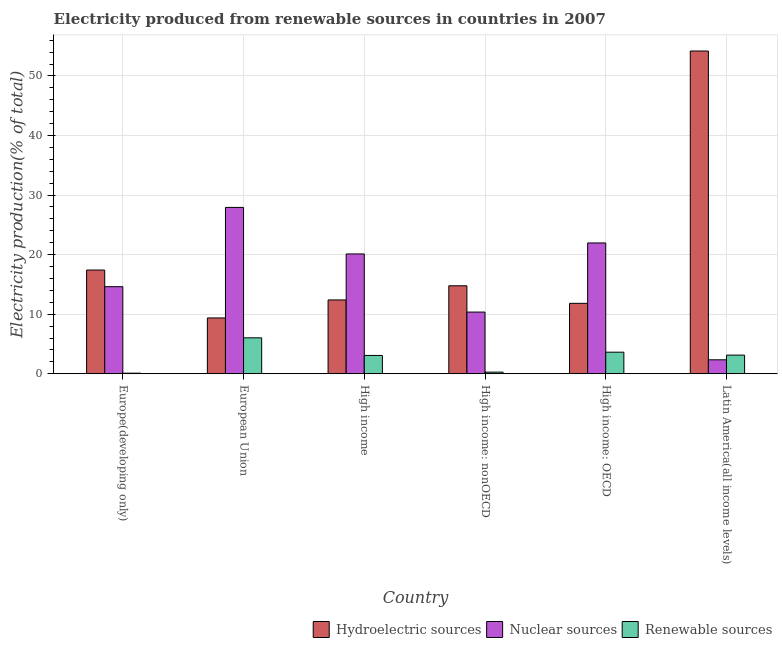How many different coloured bars are there?
Your answer should be compact. 3. How many groups of bars are there?
Provide a short and direct response. 6. How many bars are there on the 2nd tick from the left?
Offer a very short reply. 3. What is the label of the 6th group of bars from the left?
Your answer should be compact. Latin America(all income levels). In how many cases, is the number of bars for a given country not equal to the number of legend labels?
Keep it short and to the point. 0. What is the percentage of electricity produced by hydroelectric sources in High income: OECD?
Ensure brevity in your answer.  11.82. Across all countries, what is the maximum percentage of electricity produced by nuclear sources?
Your answer should be very brief. 27.93. Across all countries, what is the minimum percentage of electricity produced by nuclear sources?
Your answer should be very brief. 2.34. In which country was the percentage of electricity produced by renewable sources minimum?
Ensure brevity in your answer.  Europe(developing only). What is the total percentage of electricity produced by renewable sources in the graph?
Ensure brevity in your answer.  16.22. What is the difference between the percentage of electricity produced by renewable sources in European Union and that in Latin America(all income levels)?
Your answer should be compact. 2.9. What is the difference between the percentage of electricity produced by hydroelectric sources in Latin America(all income levels) and the percentage of electricity produced by nuclear sources in High income?
Make the answer very short. 34.07. What is the average percentage of electricity produced by renewable sources per country?
Give a very brief answer. 2.7. What is the difference between the percentage of electricity produced by renewable sources and percentage of electricity produced by hydroelectric sources in European Union?
Provide a succinct answer. -3.34. What is the ratio of the percentage of electricity produced by renewable sources in Europe(developing only) to that in European Union?
Ensure brevity in your answer.  0.02. Is the percentage of electricity produced by renewable sources in European Union less than that in High income: nonOECD?
Provide a succinct answer. No. Is the difference between the percentage of electricity produced by renewable sources in Europe(developing only) and Latin America(all income levels) greater than the difference between the percentage of electricity produced by hydroelectric sources in Europe(developing only) and Latin America(all income levels)?
Provide a short and direct response. Yes. What is the difference between the highest and the second highest percentage of electricity produced by hydroelectric sources?
Provide a succinct answer. 36.77. What is the difference between the highest and the lowest percentage of electricity produced by renewable sources?
Ensure brevity in your answer.  5.94. In how many countries, is the percentage of electricity produced by renewable sources greater than the average percentage of electricity produced by renewable sources taken over all countries?
Your response must be concise. 4. Is the sum of the percentage of electricity produced by renewable sources in European Union and High income greater than the maximum percentage of electricity produced by hydroelectric sources across all countries?
Ensure brevity in your answer.  No. What does the 3rd bar from the left in High income: nonOECD represents?
Your answer should be compact. Renewable sources. What does the 2nd bar from the right in Europe(developing only) represents?
Give a very brief answer. Nuclear sources. Are all the bars in the graph horizontal?
Your response must be concise. No. What is the difference between two consecutive major ticks on the Y-axis?
Give a very brief answer. 10. Are the values on the major ticks of Y-axis written in scientific E-notation?
Keep it short and to the point. No. Does the graph contain any zero values?
Your answer should be very brief. No. How many legend labels are there?
Provide a short and direct response. 3. How are the legend labels stacked?
Your answer should be very brief. Horizontal. What is the title of the graph?
Your answer should be compact. Electricity produced from renewable sources in countries in 2007. What is the label or title of the Y-axis?
Provide a short and direct response. Electricity production(% of total). What is the Electricity production(% of total) of Hydroelectric sources in Europe(developing only)?
Your answer should be very brief. 17.41. What is the Electricity production(% of total) of Nuclear sources in Europe(developing only)?
Offer a terse response. 14.62. What is the Electricity production(% of total) in Renewable sources in Europe(developing only)?
Your answer should be compact. 0.09. What is the Electricity production(% of total) of Hydroelectric sources in European Union?
Your answer should be very brief. 9.37. What is the Electricity production(% of total) of Nuclear sources in European Union?
Provide a succinct answer. 27.93. What is the Electricity production(% of total) of Renewable sources in European Union?
Make the answer very short. 6.03. What is the Electricity production(% of total) in Hydroelectric sources in High income?
Provide a succinct answer. 12.39. What is the Electricity production(% of total) of Nuclear sources in High income?
Offer a terse response. 20.11. What is the Electricity production(% of total) of Renewable sources in High income?
Ensure brevity in your answer.  3.07. What is the Electricity production(% of total) in Hydroelectric sources in High income: nonOECD?
Make the answer very short. 14.77. What is the Electricity production(% of total) of Nuclear sources in High income: nonOECD?
Ensure brevity in your answer.  10.36. What is the Electricity production(% of total) of Renewable sources in High income: nonOECD?
Your response must be concise. 0.27. What is the Electricity production(% of total) of Hydroelectric sources in High income: OECD?
Your answer should be very brief. 11.82. What is the Electricity production(% of total) in Nuclear sources in High income: OECD?
Provide a succinct answer. 21.96. What is the Electricity production(% of total) in Renewable sources in High income: OECD?
Your response must be concise. 3.62. What is the Electricity production(% of total) in Hydroelectric sources in Latin America(all income levels)?
Your answer should be compact. 54.19. What is the Electricity production(% of total) in Nuclear sources in Latin America(all income levels)?
Provide a succinct answer. 2.34. What is the Electricity production(% of total) in Renewable sources in Latin America(all income levels)?
Your response must be concise. 3.13. Across all countries, what is the maximum Electricity production(% of total) of Hydroelectric sources?
Offer a very short reply. 54.19. Across all countries, what is the maximum Electricity production(% of total) in Nuclear sources?
Your response must be concise. 27.93. Across all countries, what is the maximum Electricity production(% of total) in Renewable sources?
Make the answer very short. 6.03. Across all countries, what is the minimum Electricity production(% of total) of Hydroelectric sources?
Ensure brevity in your answer.  9.37. Across all countries, what is the minimum Electricity production(% of total) in Nuclear sources?
Your answer should be very brief. 2.34. Across all countries, what is the minimum Electricity production(% of total) in Renewable sources?
Provide a succinct answer. 0.09. What is the total Electricity production(% of total) in Hydroelectric sources in the graph?
Keep it short and to the point. 119.94. What is the total Electricity production(% of total) of Nuclear sources in the graph?
Give a very brief answer. 97.31. What is the total Electricity production(% of total) in Renewable sources in the graph?
Provide a short and direct response. 16.22. What is the difference between the Electricity production(% of total) of Hydroelectric sources in Europe(developing only) and that in European Union?
Give a very brief answer. 8.05. What is the difference between the Electricity production(% of total) of Nuclear sources in Europe(developing only) and that in European Union?
Your response must be concise. -13.31. What is the difference between the Electricity production(% of total) in Renewable sources in Europe(developing only) and that in European Union?
Give a very brief answer. -5.94. What is the difference between the Electricity production(% of total) in Hydroelectric sources in Europe(developing only) and that in High income?
Give a very brief answer. 5.02. What is the difference between the Electricity production(% of total) in Nuclear sources in Europe(developing only) and that in High income?
Keep it short and to the point. -5.5. What is the difference between the Electricity production(% of total) of Renewable sources in Europe(developing only) and that in High income?
Provide a short and direct response. -2.98. What is the difference between the Electricity production(% of total) in Hydroelectric sources in Europe(developing only) and that in High income: nonOECD?
Ensure brevity in your answer.  2.65. What is the difference between the Electricity production(% of total) in Nuclear sources in Europe(developing only) and that in High income: nonOECD?
Ensure brevity in your answer.  4.26. What is the difference between the Electricity production(% of total) of Renewable sources in Europe(developing only) and that in High income: nonOECD?
Give a very brief answer. -0.18. What is the difference between the Electricity production(% of total) in Hydroelectric sources in Europe(developing only) and that in High income: OECD?
Provide a succinct answer. 5.59. What is the difference between the Electricity production(% of total) of Nuclear sources in Europe(developing only) and that in High income: OECD?
Your answer should be compact. -7.34. What is the difference between the Electricity production(% of total) of Renewable sources in Europe(developing only) and that in High income: OECD?
Offer a terse response. -3.53. What is the difference between the Electricity production(% of total) of Hydroelectric sources in Europe(developing only) and that in Latin America(all income levels)?
Your answer should be very brief. -36.77. What is the difference between the Electricity production(% of total) in Nuclear sources in Europe(developing only) and that in Latin America(all income levels)?
Keep it short and to the point. 12.28. What is the difference between the Electricity production(% of total) of Renewable sources in Europe(developing only) and that in Latin America(all income levels)?
Ensure brevity in your answer.  -3.03. What is the difference between the Electricity production(% of total) of Hydroelectric sources in European Union and that in High income?
Keep it short and to the point. -3.02. What is the difference between the Electricity production(% of total) of Nuclear sources in European Union and that in High income?
Provide a succinct answer. 7.81. What is the difference between the Electricity production(% of total) in Renewable sources in European Union and that in High income?
Your answer should be very brief. 2.96. What is the difference between the Electricity production(% of total) in Hydroelectric sources in European Union and that in High income: nonOECD?
Provide a succinct answer. -5.4. What is the difference between the Electricity production(% of total) in Nuclear sources in European Union and that in High income: nonOECD?
Ensure brevity in your answer.  17.57. What is the difference between the Electricity production(% of total) of Renewable sources in European Union and that in High income: nonOECD?
Provide a succinct answer. 5.76. What is the difference between the Electricity production(% of total) in Hydroelectric sources in European Union and that in High income: OECD?
Keep it short and to the point. -2.45. What is the difference between the Electricity production(% of total) in Nuclear sources in European Union and that in High income: OECD?
Make the answer very short. 5.97. What is the difference between the Electricity production(% of total) in Renewable sources in European Union and that in High income: OECD?
Your answer should be very brief. 2.41. What is the difference between the Electricity production(% of total) of Hydroelectric sources in European Union and that in Latin America(all income levels)?
Provide a succinct answer. -44.82. What is the difference between the Electricity production(% of total) in Nuclear sources in European Union and that in Latin America(all income levels)?
Make the answer very short. 25.59. What is the difference between the Electricity production(% of total) in Renewable sources in European Union and that in Latin America(all income levels)?
Your answer should be compact. 2.9. What is the difference between the Electricity production(% of total) in Hydroelectric sources in High income and that in High income: nonOECD?
Provide a short and direct response. -2.38. What is the difference between the Electricity production(% of total) of Nuclear sources in High income and that in High income: nonOECD?
Your answer should be compact. 9.76. What is the difference between the Electricity production(% of total) in Renewable sources in High income and that in High income: nonOECD?
Your answer should be very brief. 2.8. What is the difference between the Electricity production(% of total) in Hydroelectric sources in High income and that in High income: OECD?
Provide a short and direct response. 0.57. What is the difference between the Electricity production(% of total) in Nuclear sources in High income and that in High income: OECD?
Your response must be concise. -1.85. What is the difference between the Electricity production(% of total) in Renewable sources in High income and that in High income: OECD?
Make the answer very short. -0.55. What is the difference between the Electricity production(% of total) in Hydroelectric sources in High income and that in Latin America(all income levels)?
Offer a terse response. -41.8. What is the difference between the Electricity production(% of total) in Nuclear sources in High income and that in Latin America(all income levels)?
Give a very brief answer. 17.77. What is the difference between the Electricity production(% of total) of Renewable sources in High income and that in Latin America(all income levels)?
Make the answer very short. -0.06. What is the difference between the Electricity production(% of total) in Hydroelectric sources in High income: nonOECD and that in High income: OECD?
Your answer should be very brief. 2.95. What is the difference between the Electricity production(% of total) of Nuclear sources in High income: nonOECD and that in High income: OECD?
Keep it short and to the point. -11.6. What is the difference between the Electricity production(% of total) of Renewable sources in High income: nonOECD and that in High income: OECD?
Your answer should be compact. -3.35. What is the difference between the Electricity production(% of total) of Hydroelectric sources in High income: nonOECD and that in Latin America(all income levels)?
Give a very brief answer. -39.42. What is the difference between the Electricity production(% of total) of Nuclear sources in High income: nonOECD and that in Latin America(all income levels)?
Keep it short and to the point. 8.02. What is the difference between the Electricity production(% of total) of Renewable sources in High income: nonOECD and that in Latin America(all income levels)?
Ensure brevity in your answer.  -2.85. What is the difference between the Electricity production(% of total) of Hydroelectric sources in High income: OECD and that in Latin America(all income levels)?
Give a very brief answer. -42.37. What is the difference between the Electricity production(% of total) in Nuclear sources in High income: OECD and that in Latin America(all income levels)?
Provide a succinct answer. 19.62. What is the difference between the Electricity production(% of total) of Renewable sources in High income: OECD and that in Latin America(all income levels)?
Keep it short and to the point. 0.49. What is the difference between the Electricity production(% of total) of Hydroelectric sources in Europe(developing only) and the Electricity production(% of total) of Nuclear sources in European Union?
Provide a succinct answer. -10.51. What is the difference between the Electricity production(% of total) of Hydroelectric sources in Europe(developing only) and the Electricity production(% of total) of Renewable sources in European Union?
Your answer should be very brief. 11.38. What is the difference between the Electricity production(% of total) of Nuclear sources in Europe(developing only) and the Electricity production(% of total) of Renewable sources in European Union?
Offer a very short reply. 8.58. What is the difference between the Electricity production(% of total) of Hydroelectric sources in Europe(developing only) and the Electricity production(% of total) of Nuclear sources in High income?
Provide a succinct answer. -2.7. What is the difference between the Electricity production(% of total) of Hydroelectric sources in Europe(developing only) and the Electricity production(% of total) of Renewable sources in High income?
Your answer should be very brief. 14.34. What is the difference between the Electricity production(% of total) in Nuclear sources in Europe(developing only) and the Electricity production(% of total) in Renewable sources in High income?
Provide a short and direct response. 11.54. What is the difference between the Electricity production(% of total) of Hydroelectric sources in Europe(developing only) and the Electricity production(% of total) of Nuclear sources in High income: nonOECD?
Your answer should be compact. 7.06. What is the difference between the Electricity production(% of total) of Hydroelectric sources in Europe(developing only) and the Electricity production(% of total) of Renewable sources in High income: nonOECD?
Offer a very short reply. 17.14. What is the difference between the Electricity production(% of total) in Nuclear sources in Europe(developing only) and the Electricity production(% of total) in Renewable sources in High income: nonOECD?
Provide a succinct answer. 14.34. What is the difference between the Electricity production(% of total) in Hydroelectric sources in Europe(developing only) and the Electricity production(% of total) in Nuclear sources in High income: OECD?
Make the answer very short. -4.55. What is the difference between the Electricity production(% of total) of Hydroelectric sources in Europe(developing only) and the Electricity production(% of total) of Renewable sources in High income: OECD?
Offer a very short reply. 13.79. What is the difference between the Electricity production(% of total) of Nuclear sources in Europe(developing only) and the Electricity production(% of total) of Renewable sources in High income: OECD?
Give a very brief answer. 11. What is the difference between the Electricity production(% of total) in Hydroelectric sources in Europe(developing only) and the Electricity production(% of total) in Nuclear sources in Latin America(all income levels)?
Offer a very short reply. 15.07. What is the difference between the Electricity production(% of total) of Hydroelectric sources in Europe(developing only) and the Electricity production(% of total) of Renewable sources in Latin America(all income levels)?
Give a very brief answer. 14.28. What is the difference between the Electricity production(% of total) in Nuclear sources in Europe(developing only) and the Electricity production(% of total) in Renewable sources in Latin America(all income levels)?
Keep it short and to the point. 11.49. What is the difference between the Electricity production(% of total) of Hydroelectric sources in European Union and the Electricity production(% of total) of Nuclear sources in High income?
Offer a very short reply. -10.75. What is the difference between the Electricity production(% of total) of Hydroelectric sources in European Union and the Electricity production(% of total) of Renewable sources in High income?
Make the answer very short. 6.29. What is the difference between the Electricity production(% of total) in Nuclear sources in European Union and the Electricity production(% of total) in Renewable sources in High income?
Keep it short and to the point. 24.85. What is the difference between the Electricity production(% of total) in Hydroelectric sources in European Union and the Electricity production(% of total) in Nuclear sources in High income: nonOECD?
Ensure brevity in your answer.  -0.99. What is the difference between the Electricity production(% of total) of Hydroelectric sources in European Union and the Electricity production(% of total) of Renewable sources in High income: nonOECD?
Your answer should be very brief. 9.09. What is the difference between the Electricity production(% of total) in Nuclear sources in European Union and the Electricity production(% of total) in Renewable sources in High income: nonOECD?
Make the answer very short. 27.65. What is the difference between the Electricity production(% of total) in Hydroelectric sources in European Union and the Electricity production(% of total) in Nuclear sources in High income: OECD?
Your answer should be compact. -12.59. What is the difference between the Electricity production(% of total) in Hydroelectric sources in European Union and the Electricity production(% of total) in Renewable sources in High income: OECD?
Your answer should be compact. 5.75. What is the difference between the Electricity production(% of total) in Nuclear sources in European Union and the Electricity production(% of total) in Renewable sources in High income: OECD?
Give a very brief answer. 24.3. What is the difference between the Electricity production(% of total) in Hydroelectric sources in European Union and the Electricity production(% of total) in Nuclear sources in Latin America(all income levels)?
Your answer should be compact. 7.03. What is the difference between the Electricity production(% of total) in Hydroelectric sources in European Union and the Electricity production(% of total) in Renewable sources in Latin America(all income levels)?
Ensure brevity in your answer.  6.24. What is the difference between the Electricity production(% of total) in Nuclear sources in European Union and the Electricity production(% of total) in Renewable sources in Latin America(all income levels)?
Your answer should be very brief. 24.8. What is the difference between the Electricity production(% of total) in Hydroelectric sources in High income and the Electricity production(% of total) in Nuclear sources in High income: nonOECD?
Provide a succinct answer. 2.03. What is the difference between the Electricity production(% of total) in Hydroelectric sources in High income and the Electricity production(% of total) in Renewable sources in High income: nonOECD?
Make the answer very short. 12.12. What is the difference between the Electricity production(% of total) in Nuclear sources in High income and the Electricity production(% of total) in Renewable sources in High income: nonOECD?
Ensure brevity in your answer.  19.84. What is the difference between the Electricity production(% of total) in Hydroelectric sources in High income and the Electricity production(% of total) in Nuclear sources in High income: OECD?
Give a very brief answer. -9.57. What is the difference between the Electricity production(% of total) of Hydroelectric sources in High income and the Electricity production(% of total) of Renewable sources in High income: OECD?
Offer a very short reply. 8.77. What is the difference between the Electricity production(% of total) of Nuclear sources in High income and the Electricity production(% of total) of Renewable sources in High income: OECD?
Provide a succinct answer. 16.49. What is the difference between the Electricity production(% of total) in Hydroelectric sources in High income and the Electricity production(% of total) in Nuclear sources in Latin America(all income levels)?
Provide a succinct answer. 10.05. What is the difference between the Electricity production(% of total) in Hydroelectric sources in High income and the Electricity production(% of total) in Renewable sources in Latin America(all income levels)?
Your response must be concise. 9.26. What is the difference between the Electricity production(% of total) of Nuclear sources in High income and the Electricity production(% of total) of Renewable sources in Latin America(all income levels)?
Make the answer very short. 16.99. What is the difference between the Electricity production(% of total) in Hydroelectric sources in High income: nonOECD and the Electricity production(% of total) in Nuclear sources in High income: OECD?
Ensure brevity in your answer.  -7.19. What is the difference between the Electricity production(% of total) in Hydroelectric sources in High income: nonOECD and the Electricity production(% of total) in Renewable sources in High income: OECD?
Your response must be concise. 11.15. What is the difference between the Electricity production(% of total) in Nuclear sources in High income: nonOECD and the Electricity production(% of total) in Renewable sources in High income: OECD?
Your answer should be very brief. 6.73. What is the difference between the Electricity production(% of total) of Hydroelectric sources in High income: nonOECD and the Electricity production(% of total) of Nuclear sources in Latin America(all income levels)?
Keep it short and to the point. 12.43. What is the difference between the Electricity production(% of total) of Hydroelectric sources in High income: nonOECD and the Electricity production(% of total) of Renewable sources in Latin America(all income levels)?
Offer a very short reply. 11.64. What is the difference between the Electricity production(% of total) of Nuclear sources in High income: nonOECD and the Electricity production(% of total) of Renewable sources in Latin America(all income levels)?
Offer a terse response. 7.23. What is the difference between the Electricity production(% of total) of Hydroelectric sources in High income: OECD and the Electricity production(% of total) of Nuclear sources in Latin America(all income levels)?
Keep it short and to the point. 9.48. What is the difference between the Electricity production(% of total) in Hydroelectric sources in High income: OECD and the Electricity production(% of total) in Renewable sources in Latin America(all income levels)?
Your response must be concise. 8.69. What is the difference between the Electricity production(% of total) in Nuclear sources in High income: OECD and the Electricity production(% of total) in Renewable sources in Latin America(all income levels)?
Provide a short and direct response. 18.83. What is the average Electricity production(% of total) in Hydroelectric sources per country?
Offer a very short reply. 19.99. What is the average Electricity production(% of total) in Nuclear sources per country?
Make the answer very short. 16.22. What is the average Electricity production(% of total) in Renewable sources per country?
Make the answer very short. 2.7. What is the difference between the Electricity production(% of total) of Hydroelectric sources and Electricity production(% of total) of Nuclear sources in Europe(developing only)?
Make the answer very short. 2.8. What is the difference between the Electricity production(% of total) in Hydroelectric sources and Electricity production(% of total) in Renewable sources in Europe(developing only)?
Your response must be concise. 17.32. What is the difference between the Electricity production(% of total) of Nuclear sources and Electricity production(% of total) of Renewable sources in Europe(developing only)?
Make the answer very short. 14.52. What is the difference between the Electricity production(% of total) in Hydroelectric sources and Electricity production(% of total) in Nuclear sources in European Union?
Your answer should be compact. -18.56. What is the difference between the Electricity production(% of total) of Hydroelectric sources and Electricity production(% of total) of Renewable sources in European Union?
Give a very brief answer. 3.34. What is the difference between the Electricity production(% of total) in Nuclear sources and Electricity production(% of total) in Renewable sources in European Union?
Ensure brevity in your answer.  21.89. What is the difference between the Electricity production(% of total) of Hydroelectric sources and Electricity production(% of total) of Nuclear sources in High income?
Make the answer very short. -7.72. What is the difference between the Electricity production(% of total) of Hydroelectric sources and Electricity production(% of total) of Renewable sources in High income?
Offer a terse response. 9.32. What is the difference between the Electricity production(% of total) of Nuclear sources and Electricity production(% of total) of Renewable sources in High income?
Your answer should be compact. 17.04. What is the difference between the Electricity production(% of total) of Hydroelectric sources and Electricity production(% of total) of Nuclear sources in High income: nonOECD?
Offer a very short reply. 4.41. What is the difference between the Electricity production(% of total) in Hydroelectric sources and Electricity production(% of total) in Renewable sources in High income: nonOECD?
Your response must be concise. 14.49. What is the difference between the Electricity production(% of total) of Nuclear sources and Electricity production(% of total) of Renewable sources in High income: nonOECD?
Provide a short and direct response. 10.08. What is the difference between the Electricity production(% of total) of Hydroelectric sources and Electricity production(% of total) of Nuclear sources in High income: OECD?
Keep it short and to the point. -10.14. What is the difference between the Electricity production(% of total) of Hydroelectric sources and Electricity production(% of total) of Renewable sources in High income: OECD?
Provide a short and direct response. 8.2. What is the difference between the Electricity production(% of total) of Nuclear sources and Electricity production(% of total) of Renewable sources in High income: OECD?
Make the answer very short. 18.34. What is the difference between the Electricity production(% of total) of Hydroelectric sources and Electricity production(% of total) of Nuclear sources in Latin America(all income levels)?
Your response must be concise. 51.85. What is the difference between the Electricity production(% of total) of Hydroelectric sources and Electricity production(% of total) of Renewable sources in Latin America(all income levels)?
Keep it short and to the point. 51.06. What is the difference between the Electricity production(% of total) of Nuclear sources and Electricity production(% of total) of Renewable sources in Latin America(all income levels)?
Your answer should be very brief. -0.79. What is the ratio of the Electricity production(% of total) in Hydroelectric sources in Europe(developing only) to that in European Union?
Offer a very short reply. 1.86. What is the ratio of the Electricity production(% of total) in Nuclear sources in Europe(developing only) to that in European Union?
Offer a terse response. 0.52. What is the ratio of the Electricity production(% of total) in Renewable sources in Europe(developing only) to that in European Union?
Provide a short and direct response. 0.02. What is the ratio of the Electricity production(% of total) in Hydroelectric sources in Europe(developing only) to that in High income?
Your answer should be compact. 1.41. What is the ratio of the Electricity production(% of total) in Nuclear sources in Europe(developing only) to that in High income?
Provide a short and direct response. 0.73. What is the ratio of the Electricity production(% of total) of Renewable sources in Europe(developing only) to that in High income?
Provide a succinct answer. 0.03. What is the ratio of the Electricity production(% of total) in Hydroelectric sources in Europe(developing only) to that in High income: nonOECD?
Offer a very short reply. 1.18. What is the ratio of the Electricity production(% of total) in Nuclear sources in Europe(developing only) to that in High income: nonOECD?
Ensure brevity in your answer.  1.41. What is the ratio of the Electricity production(% of total) in Renewable sources in Europe(developing only) to that in High income: nonOECD?
Your answer should be very brief. 0.34. What is the ratio of the Electricity production(% of total) of Hydroelectric sources in Europe(developing only) to that in High income: OECD?
Your answer should be very brief. 1.47. What is the ratio of the Electricity production(% of total) of Nuclear sources in Europe(developing only) to that in High income: OECD?
Ensure brevity in your answer.  0.67. What is the ratio of the Electricity production(% of total) in Renewable sources in Europe(developing only) to that in High income: OECD?
Your answer should be very brief. 0.03. What is the ratio of the Electricity production(% of total) of Hydroelectric sources in Europe(developing only) to that in Latin America(all income levels)?
Keep it short and to the point. 0.32. What is the ratio of the Electricity production(% of total) of Nuclear sources in Europe(developing only) to that in Latin America(all income levels)?
Make the answer very short. 6.25. What is the ratio of the Electricity production(% of total) of Hydroelectric sources in European Union to that in High income?
Provide a succinct answer. 0.76. What is the ratio of the Electricity production(% of total) in Nuclear sources in European Union to that in High income?
Make the answer very short. 1.39. What is the ratio of the Electricity production(% of total) in Renewable sources in European Union to that in High income?
Give a very brief answer. 1.96. What is the ratio of the Electricity production(% of total) of Hydroelectric sources in European Union to that in High income: nonOECD?
Offer a very short reply. 0.63. What is the ratio of the Electricity production(% of total) in Nuclear sources in European Union to that in High income: nonOECD?
Give a very brief answer. 2.7. What is the ratio of the Electricity production(% of total) in Renewable sources in European Union to that in High income: nonOECD?
Provide a short and direct response. 22.08. What is the ratio of the Electricity production(% of total) in Hydroelectric sources in European Union to that in High income: OECD?
Offer a terse response. 0.79. What is the ratio of the Electricity production(% of total) of Nuclear sources in European Union to that in High income: OECD?
Offer a very short reply. 1.27. What is the ratio of the Electricity production(% of total) of Renewable sources in European Union to that in High income: OECD?
Make the answer very short. 1.67. What is the ratio of the Electricity production(% of total) of Hydroelectric sources in European Union to that in Latin America(all income levels)?
Make the answer very short. 0.17. What is the ratio of the Electricity production(% of total) in Nuclear sources in European Union to that in Latin America(all income levels)?
Your answer should be very brief. 11.94. What is the ratio of the Electricity production(% of total) of Renewable sources in European Union to that in Latin America(all income levels)?
Offer a very short reply. 1.93. What is the ratio of the Electricity production(% of total) in Hydroelectric sources in High income to that in High income: nonOECD?
Offer a terse response. 0.84. What is the ratio of the Electricity production(% of total) of Nuclear sources in High income to that in High income: nonOECD?
Your response must be concise. 1.94. What is the ratio of the Electricity production(% of total) of Renewable sources in High income to that in High income: nonOECD?
Ensure brevity in your answer.  11.25. What is the ratio of the Electricity production(% of total) of Hydroelectric sources in High income to that in High income: OECD?
Provide a short and direct response. 1.05. What is the ratio of the Electricity production(% of total) of Nuclear sources in High income to that in High income: OECD?
Provide a short and direct response. 0.92. What is the ratio of the Electricity production(% of total) in Renewable sources in High income to that in High income: OECD?
Keep it short and to the point. 0.85. What is the ratio of the Electricity production(% of total) in Hydroelectric sources in High income to that in Latin America(all income levels)?
Give a very brief answer. 0.23. What is the ratio of the Electricity production(% of total) of Nuclear sources in High income to that in Latin America(all income levels)?
Your answer should be compact. 8.6. What is the ratio of the Electricity production(% of total) of Renewable sources in High income to that in Latin America(all income levels)?
Offer a very short reply. 0.98. What is the ratio of the Electricity production(% of total) of Hydroelectric sources in High income: nonOECD to that in High income: OECD?
Offer a very short reply. 1.25. What is the ratio of the Electricity production(% of total) of Nuclear sources in High income: nonOECD to that in High income: OECD?
Keep it short and to the point. 0.47. What is the ratio of the Electricity production(% of total) of Renewable sources in High income: nonOECD to that in High income: OECD?
Your response must be concise. 0.08. What is the ratio of the Electricity production(% of total) in Hydroelectric sources in High income: nonOECD to that in Latin America(all income levels)?
Provide a short and direct response. 0.27. What is the ratio of the Electricity production(% of total) of Nuclear sources in High income: nonOECD to that in Latin America(all income levels)?
Provide a succinct answer. 4.43. What is the ratio of the Electricity production(% of total) in Renewable sources in High income: nonOECD to that in Latin America(all income levels)?
Your answer should be very brief. 0.09. What is the ratio of the Electricity production(% of total) of Hydroelectric sources in High income: OECD to that in Latin America(all income levels)?
Make the answer very short. 0.22. What is the ratio of the Electricity production(% of total) in Nuclear sources in High income: OECD to that in Latin America(all income levels)?
Ensure brevity in your answer.  9.39. What is the ratio of the Electricity production(% of total) of Renewable sources in High income: OECD to that in Latin America(all income levels)?
Your answer should be compact. 1.16. What is the difference between the highest and the second highest Electricity production(% of total) of Hydroelectric sources?
Ensure brevity in your answer.  36.77. What is the difference between the highest and the second highest Electricity production(% of total) of Nuclear sources?
Provide a succinct answer. 5.97. What is the difference between the highest and the second highest Electricity production(% of total) of Renewable sources?
Ensure brevity in your answer.  2.41. What is the difference between the highest and the lowest Electricity production(% of total) of Hydroelectric sources?
Your response must be concise. 44.82. What is the difference between the highest and the lowest Electricity production(% of total) in Nuclear sources?
Provide a succinct answer. 25.59. What is the difference between the highest and the lowest Electricity production(% of total) of Renewable sources?
Offer a terse response. 5.94. 